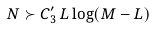Convert formula to latex. <formula><loc_0><loc_0><loc_500><loc_500>N \succ C ^ { \prime } _ { 3 } \, L \log ( M - L )</formula> 